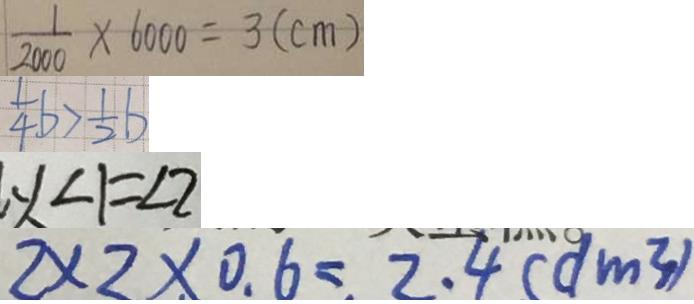<formula> <loc_0><loc_0><loc_500><loc_500>\frac { 1 } { 2 0 0 0 } \times 6 0 0 0 = 3 ( c m ) 
 \frac { 1 } { 4 } b > \frac { 1 } { 2 } b 
 y 、 \angle 1 = \angle 2 
 2 \times 2 \times 0 . 6 = 2 . 4 ( d m ^ { 3 } )</formula> 